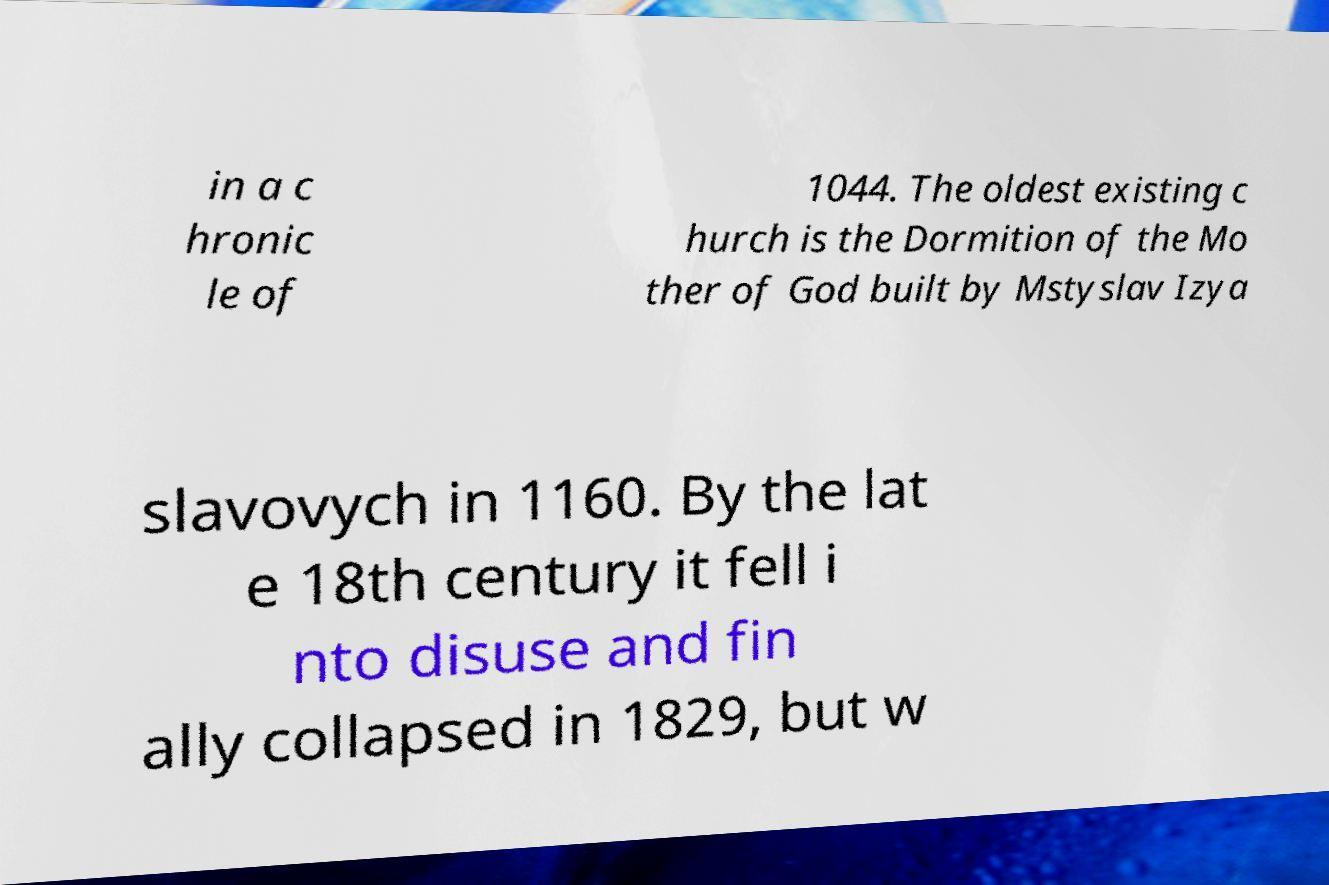I need the written content from this picture converted into text. Can you do that? in a c hronic le of 1044. The oldest existing c hurch is the Dormition of the Mo ther of God built by Mstyslav Izya slavovych in 1160. By the lat e 18th century it fell i nto disuse and fin ally collapsed in 1829, but w 